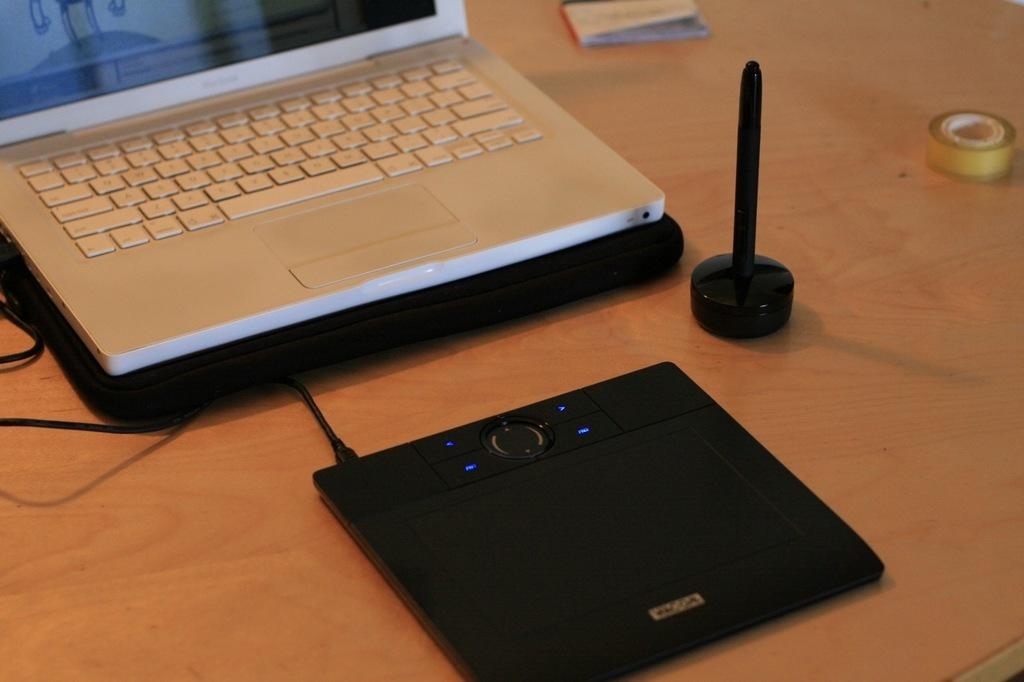What electronic device is on the table in the image? There is a laptop on the table in the image. What other objects are on the table besides the laptop? There is tape and a book on the table. Can you describe the device on the table? There is a device on the table, but its specific type is not mentioned in the facts. What might be used for attaching or securing items in the image? Tape is present on the table, which can be used for attaching or securing items. What type of sail can be seen in the image? There is no sail present in the image. What type of tin is visible on the table in the image? There is no tin present in the image. 